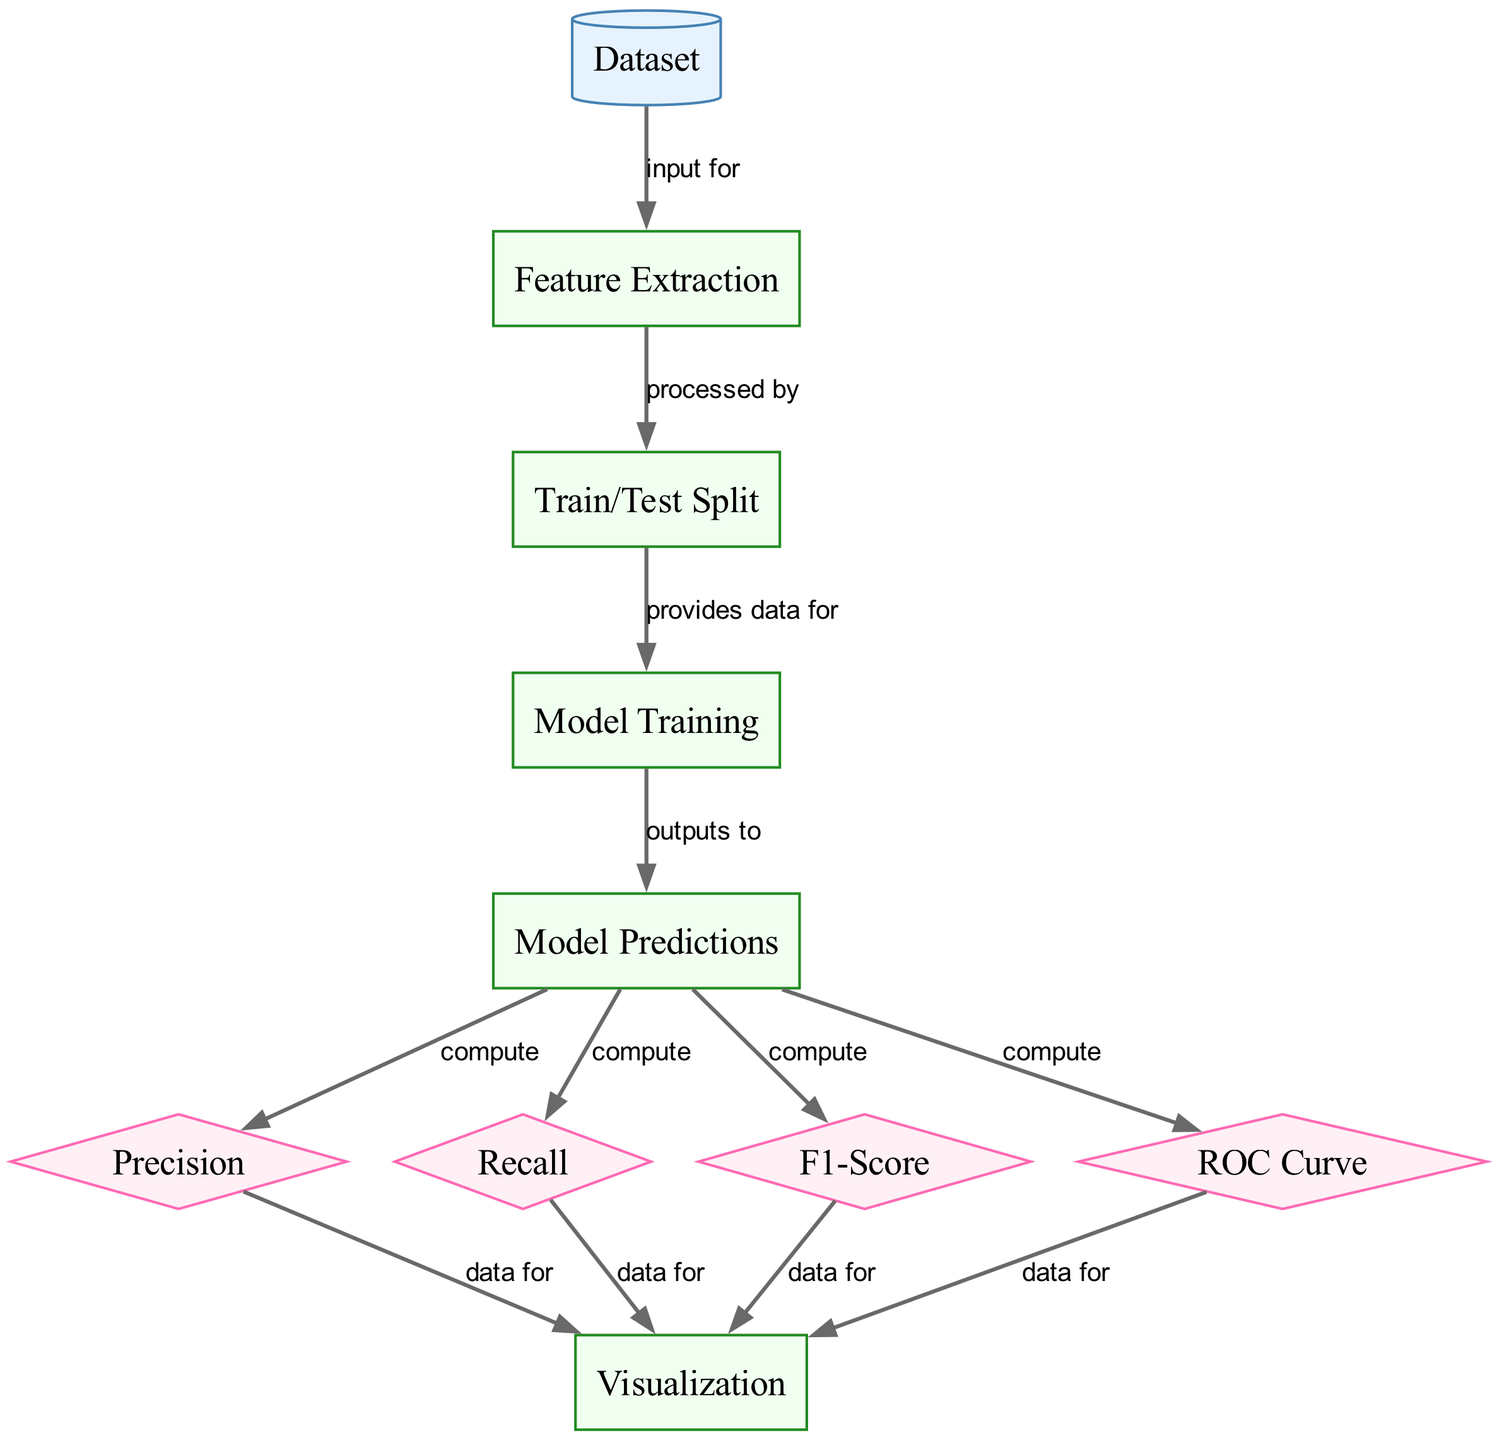What's the total number of nodes in the diagram? The diagram contains ten nodes as listed: Dataset, Feature Extraction, Train/Test Split, Model Training, Model Predictions, Precision, Recall, F1-Score, ROC Curve, and Visualization. Counting them gives a total of ten.
Answer: ten What is the output of the "Model Training" node? From the diagram, the "Model Training" node outputs to "Model Predictions," meaning it produces predictions based on the training process.
Answer: Model Predictions How many edges connect to the "Visualization" node? The "Visualization" node has four edges connecting to it: one from Precision, one from Recall, one from F1-Score, and one from ROC Curve. Therefore, there are four edges connecting to the Visualization node.
Answer: four What are the two metrics calculated directly from "Model Predictions"? The metrics computed directly from "Model Predictions" are Precision and Recall as shown by the edges leading from Model Predictions to these two nodes.
Answer: Precision, Recall Which process node directly uses the "Dataset" node as input? The edge indicates that the "Feature Extraction" node uses the "Dataset" node as input. It is clear from the first connection in the diagram that the dataset feeds into feature extraction.
Answer: Feature Extraction How do "Precision" and "Recall" relate to the "F1-Score"? "Precision" and "Recall" each provide data for the "F1-Score" which is a metric that represents the harmonic mean of both Precision and Recall. The edges from both the Precision and Recall nodes lead to the F1-Score node, indicating their role in its calculation.
Answer: data for F1-Score What is the purpose of the "ROC Curve" in the diagram? The "ROC Curve" evaluates the model's discrimination ability by showing the trade-off between true positive rate and false positive rate at various thresholds. It is an important metric to assess the performance of classification models.
Answer: Evaluates model's discrimination ability What is the sequential flow of processes from "Feature Extraction" to "Visualization"? The flow is as follows: Feature Extraction → Train/Test Split → Model Training → Model Predictions → Precision, Recall, F1-Score, ROC Curve → Visualization. This sequence outlines the data processing and evaluation leading to model performance visualization.
Answer: Feature Extraction to Visualization What information is connected to the "Model Predictions" node? The "Model Predictions" node is connected to Precision, Recall, F1-Score, and ROC Curve, indicating that it outputs pertinent information necessary for calculating these performance metrics.
Answer: Precision, Recall, F1-Score, ROC Curve 